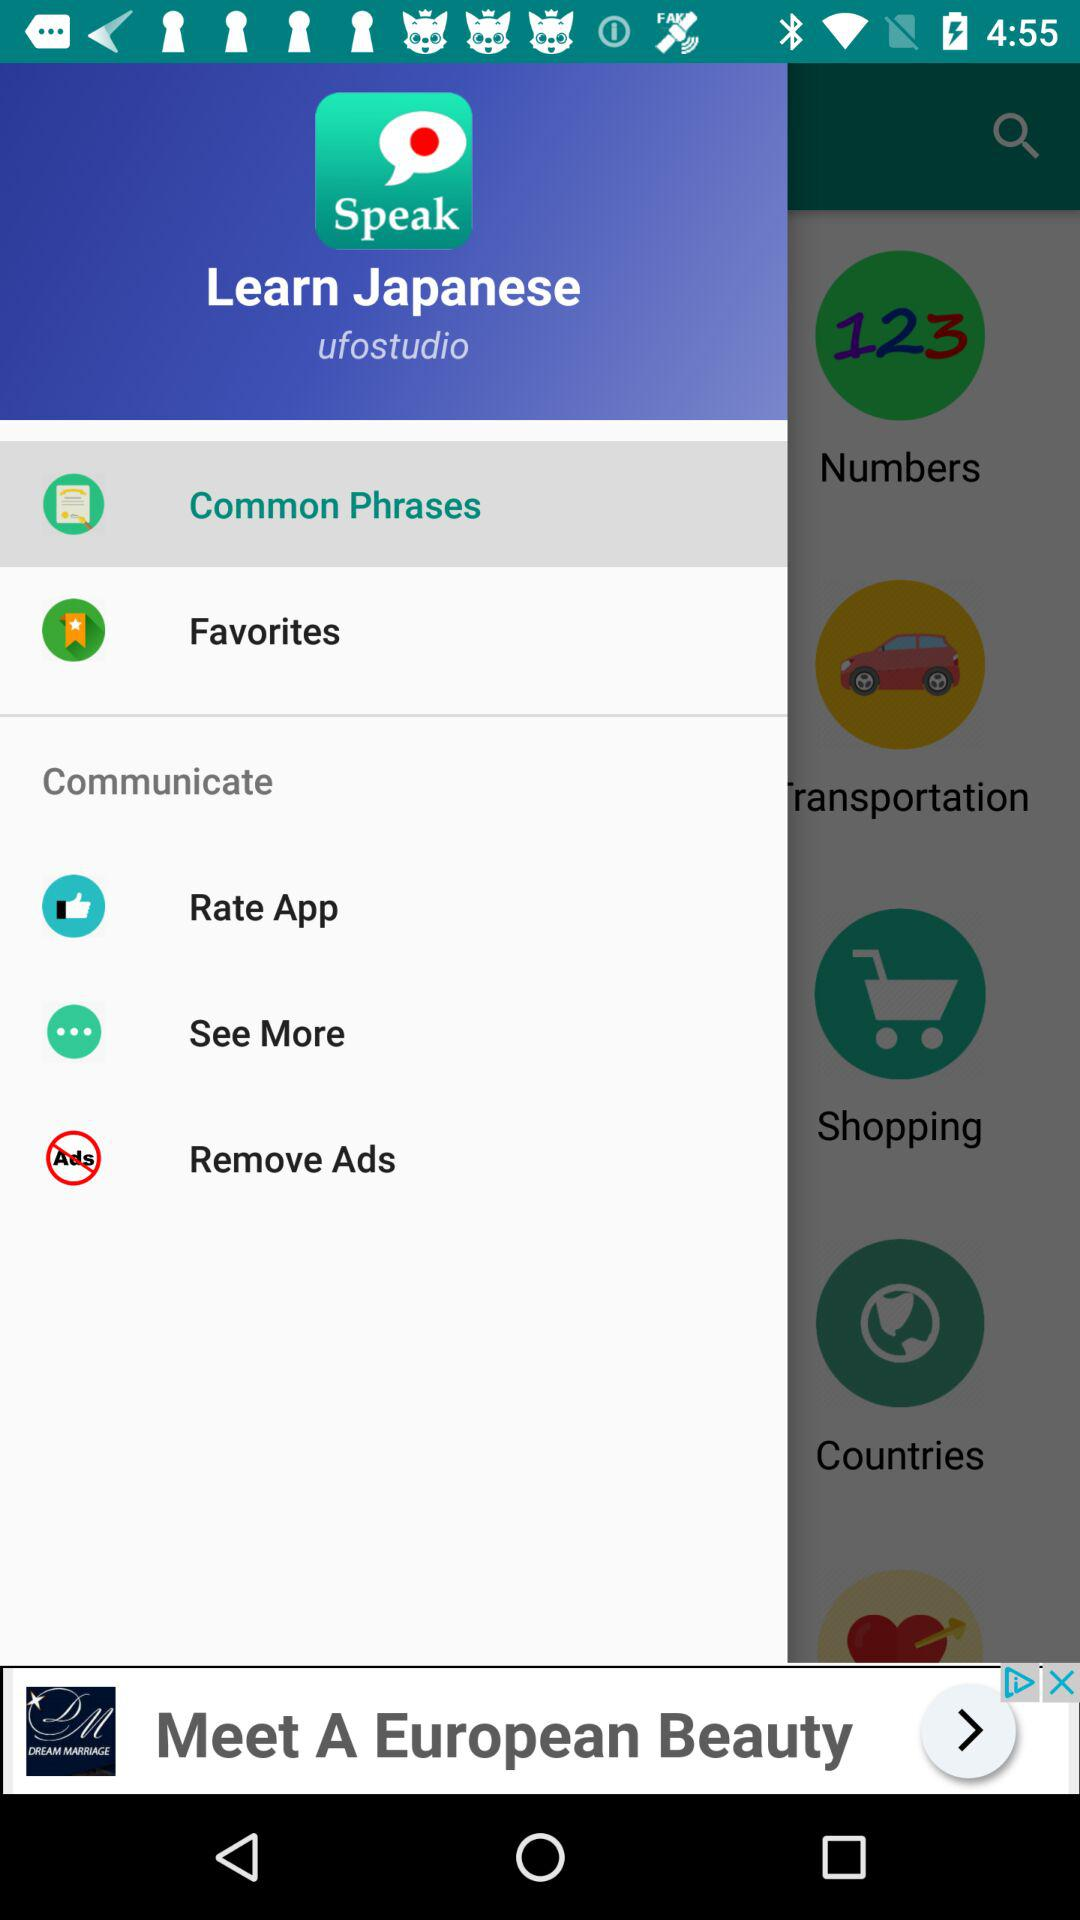What is the name of the application? The name of the application is "Speak". 